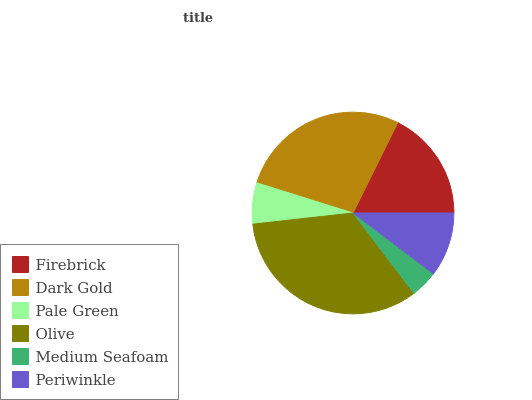Is Medium Seafoam the minimum?
Answer yes or no. Yes. Is Olive the maximum?
Answer yes or no. Yes. Is Dark Gold the minimum?
Answer yes or no. No. Is Dark Gold the maximum?
Answer yes or no. No. Is Dark Gold greater than Firebrick?
Answer yes or no. Yes. Is Firebrick less than Dark Gold?
Answer yes or no. Yes. Is Firebrick greater than Dark Gold?
Answer yes or no. No. Is Dark Gold less than Firebrick?
Answer yes or no. No. Is Firebrick the high median?
Answer yes or no. Yes. Is Periwinkle the low median?
Answer yes or no. Yes. Is Periwinkle the high median?
Answer yes or no. No. Is Medium Seafoam the low median?
Answer yes or no. No. 